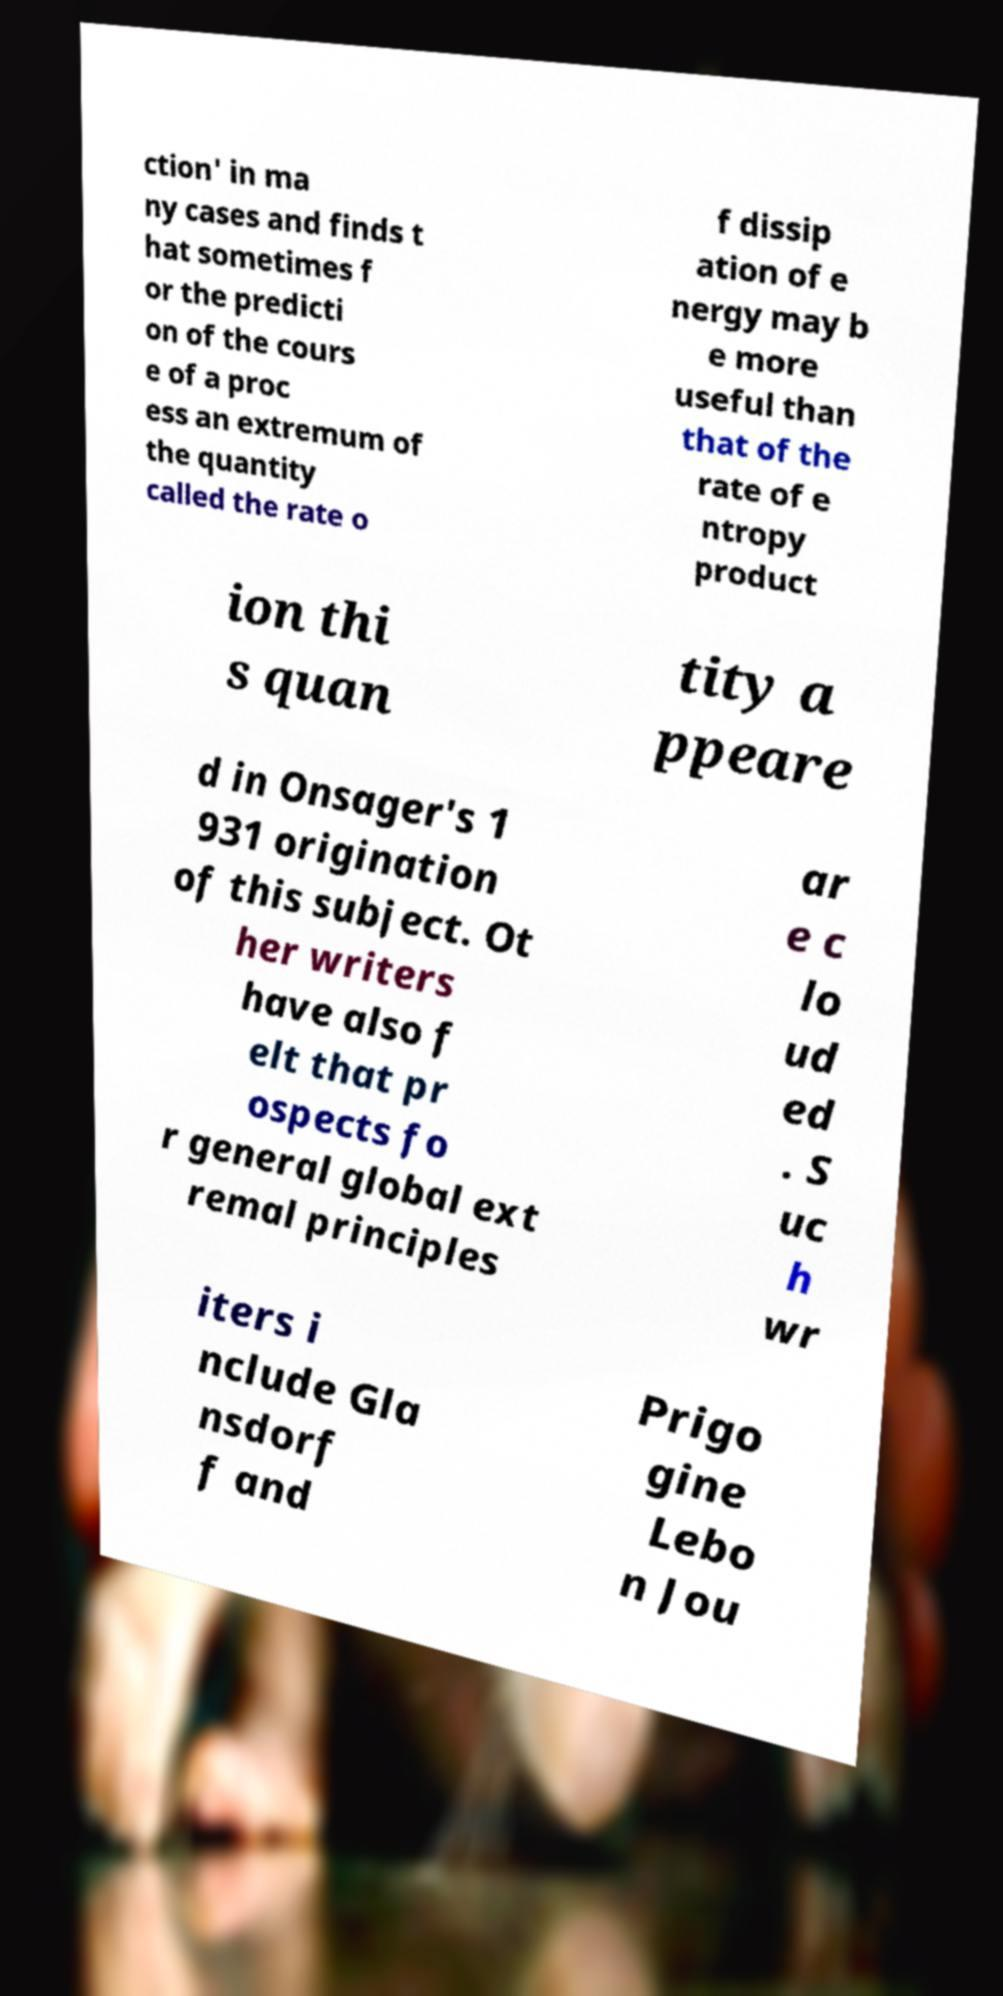I need the written content from this picture converted into text. Can you do that? ction' in ma ny cases and finds t hat sometimes f or the predicti on of the cours e of a proc ess an extremum of the quantity called the rate o f dissip ation of e nergy may b e more useful than that of the rate of e ntropy product ion thi s quan tity a ppeare d in Onsager's 1 931 origination of this subject. Ot her writers have also f elt that pr ospects fo r general global ext remal principles ar e c lo ud ed . S uc h wr iters i nclude Gla nsdorf f and Prigo gine Lebo n Jou 